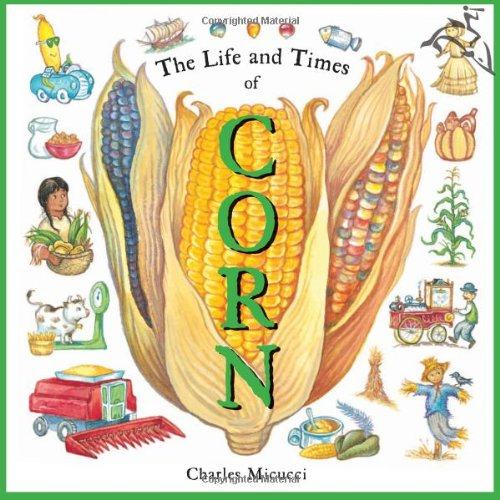Who wrote this book? Charles Micucci is the talented author of 'The Life and Times of Corn', a well-known children's book that explores the history and significance of corn in an engaging and educational manner. 